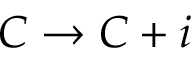Convert formula to latex. <formula><loc_0><loc_0><loc_500><loc_500>C \rightarrow C + i</formula> 